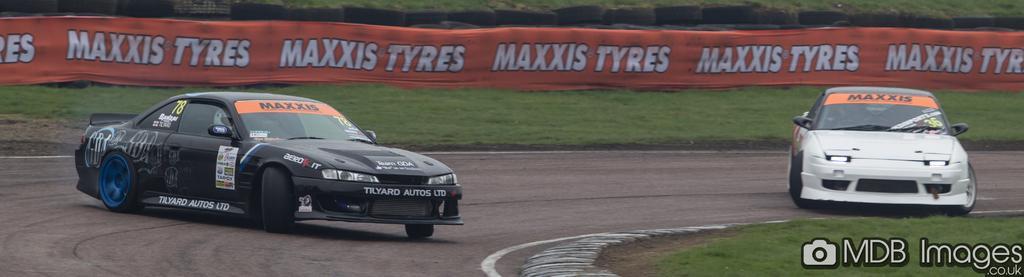Could you give a brief overview of what you see in this image? In this image there are two cars on the road and there is a grass on the surface. At the background there is a banner. Behind that there are tires. 